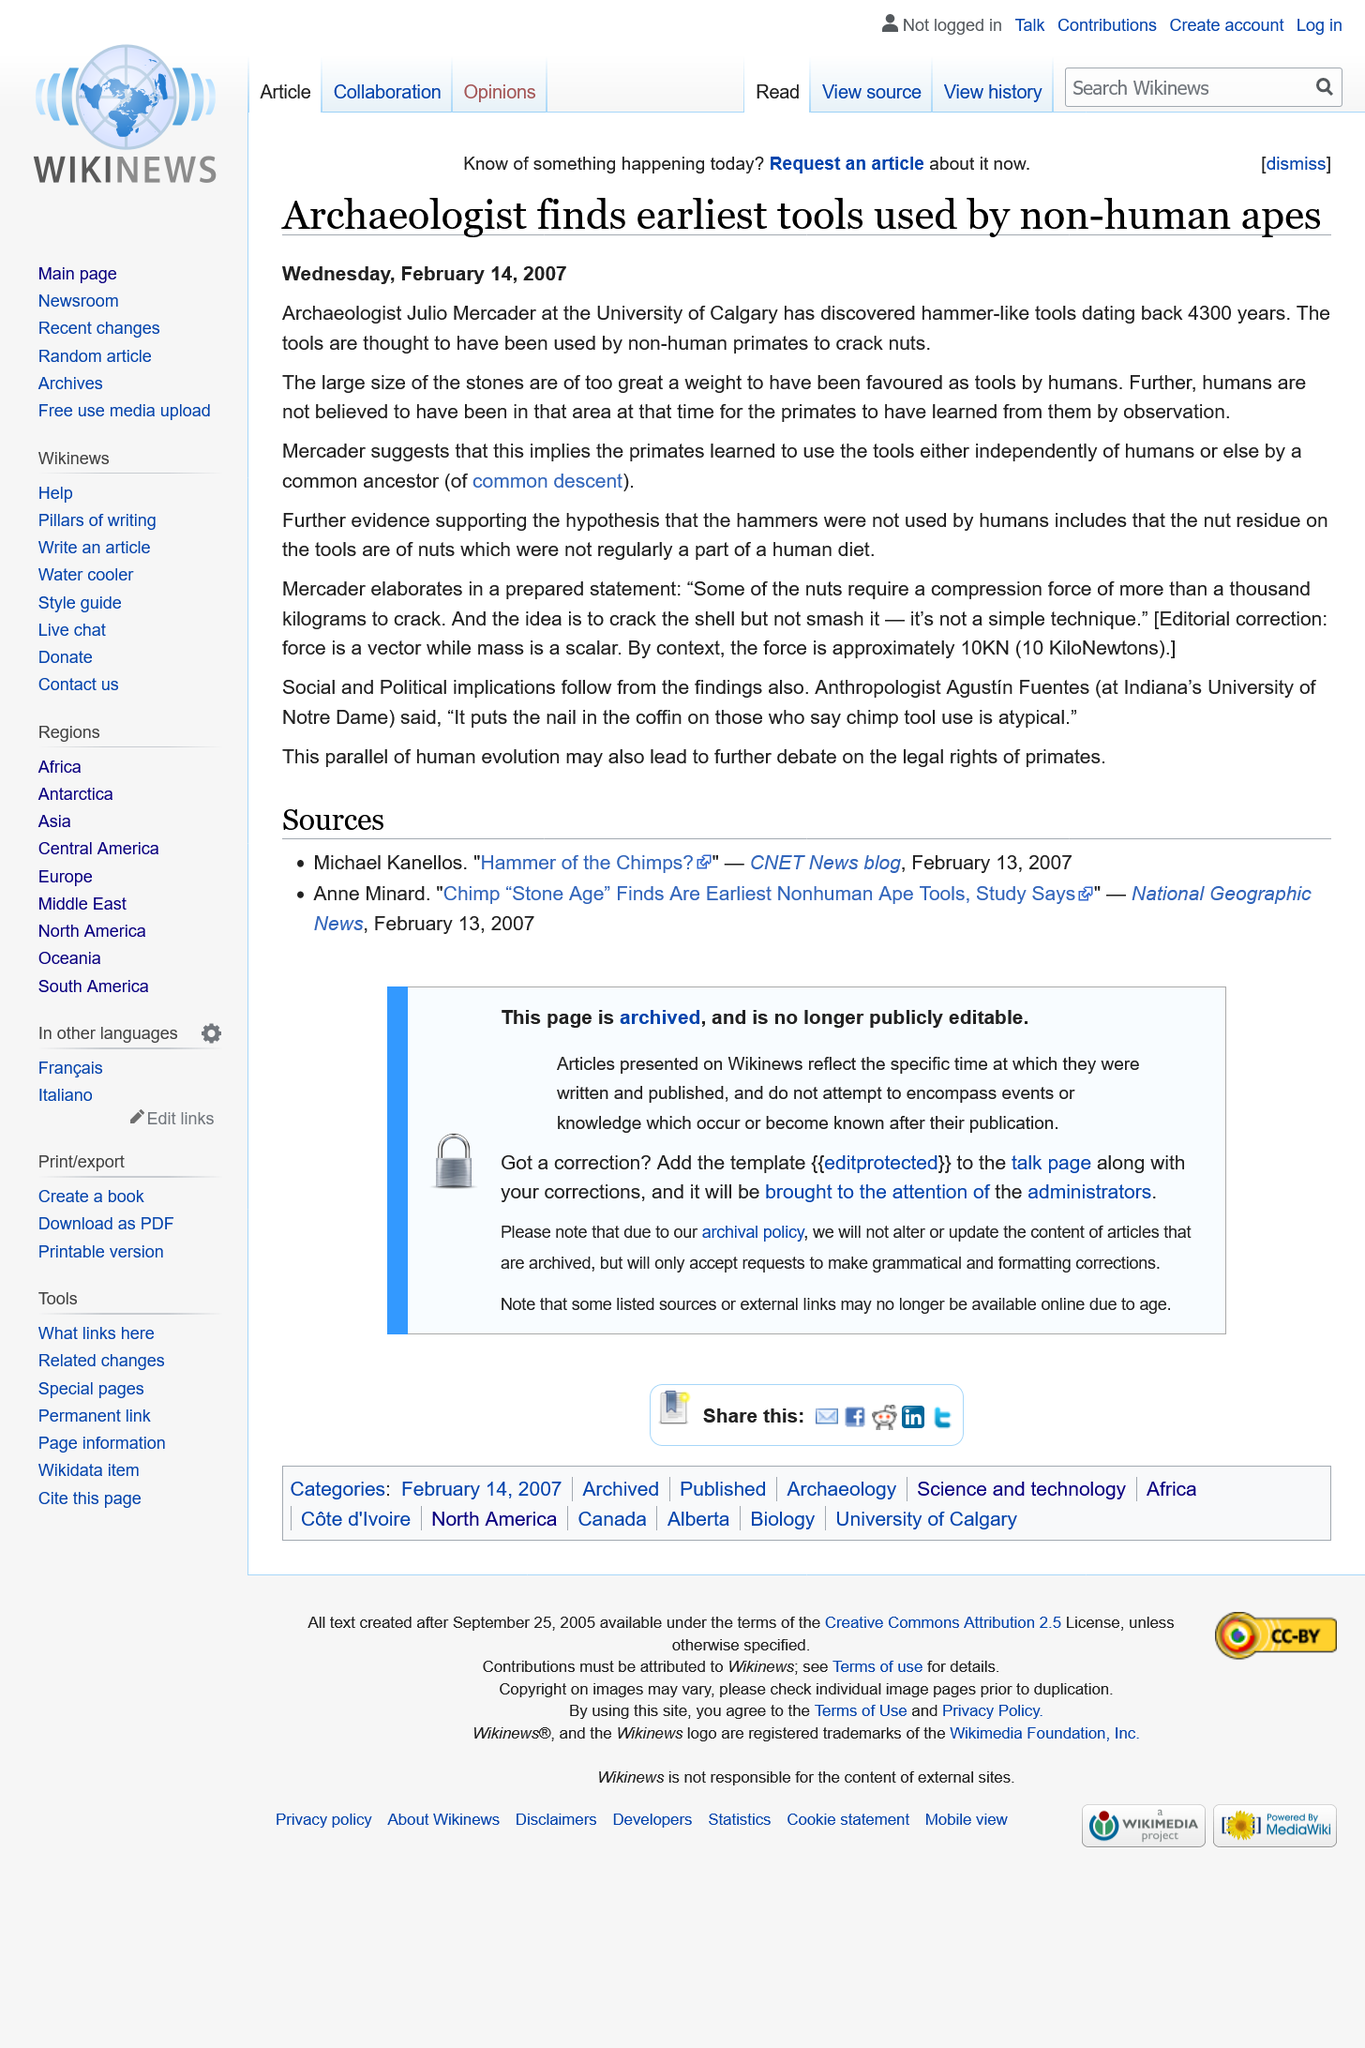List a handful of essential elements in this visual. Julio Mercader is employed by the University of Calgary. The hammer-like tools discovered by Julio Mercader are the earliest tools that have been found. The hammer-like tools date back 4300 years. 